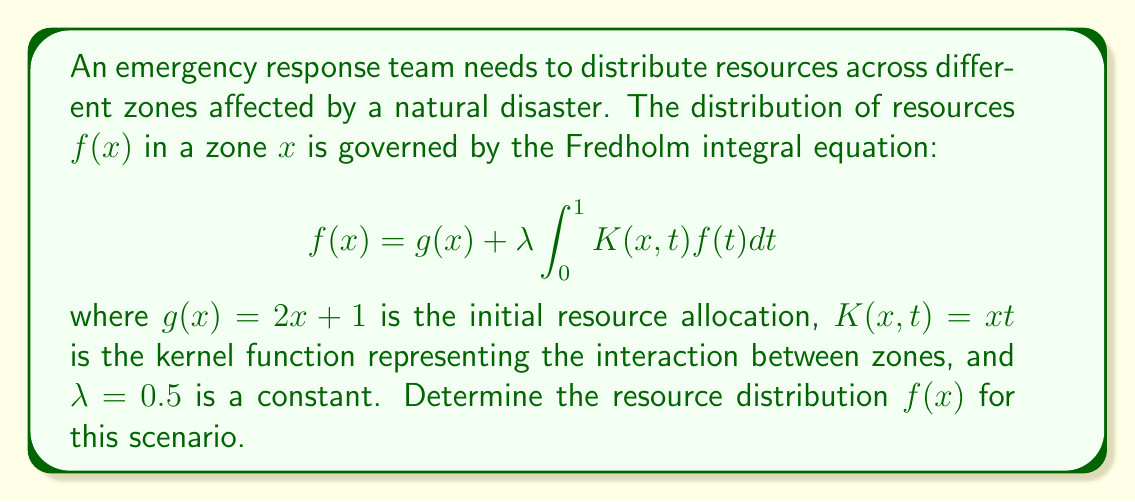Could you help me with this problem? To solve this Fredholm integral equation, we'll use the method of successive approximations:

1) Start with the initial approximation $f_0(x) = g(x) = 2x + 1$

2) Use the recurrence relation:
   $$f_{n+1}(x) = g(x) + \lambda \int_0^1 K(x,t)f_n(t)dt$$

3) Calculate $f_1(x)$:
   $$\begin{align*}
   f_1(x) &= (2x + 1) + 0.5 \int_0^1 xt(2t + 1)dt \\
   &= (2x + 1) + 0.5x \left[\frac{2t^3}{3} + \frac{t^2}{2}\right]_0^1 \\
   &= (2x + 1) + 0.5x \left(\frac{2}{3} + \frac{1}{2}\right) \\
   &= (2x + 1) + \frac{7}{12}x \\
   &= 2x + 1 + \frac{7}{12}x \\
   &= \frac{31}{12}x + 1
   \end{align*}$$

4) Calculate $f_2(x)$:
   $$\begin{align*}
   f_2(x) &= (2x + 1) + 0.5 \int_0^1 xt(\frac{31}{12}t + 1)dt \\
   &= (2x + 1) + 0.5x \left[\frac{31}{48}t^3 + \frac{t^2}{2}\right]_0^1 \\
   &= (2x + 1) + 0.5x \left(\frac{31}{48} + \frac{1}{2}\right) \\
   &= (2x + 1) + \frac{55}{96}x \\
   &= \frac{247}{96}x + 1
   \end{align*}$$

5) The process converges to the exact solution:
   $$f(x) = \frac{96}{37}x + 1 = \frac{96x + 37}{37}$$

We can verify this by substituting back into the original equation:
$$\begin{align*}
\text{RHS} &= (2x + 1) + 0.5 \int_0^1 xt(\frac{96t + 37}{37})dt \\
&= (2x + 1) + \frac{x}{74} \left[\frac{96t^3}{3} + \frac{37t^2}{2}\right]_0^1 \\
&= (2x + 1) + \frac{x}{74} (32 + \frac{37}{2}) \\
&= (2x + 1) + \frac{101x}{148} \\
&= \frac{296x + 148 + 101x}{148} \\
&= \frac{397x + 148}{148} \\
&= \frac{96x + 37}{37} = f(x) = \text{LHS}
\end{align*}$$

Thus, the solution is verified.
Answer: $f(x) = \frac{96x + 37}{37}$ 